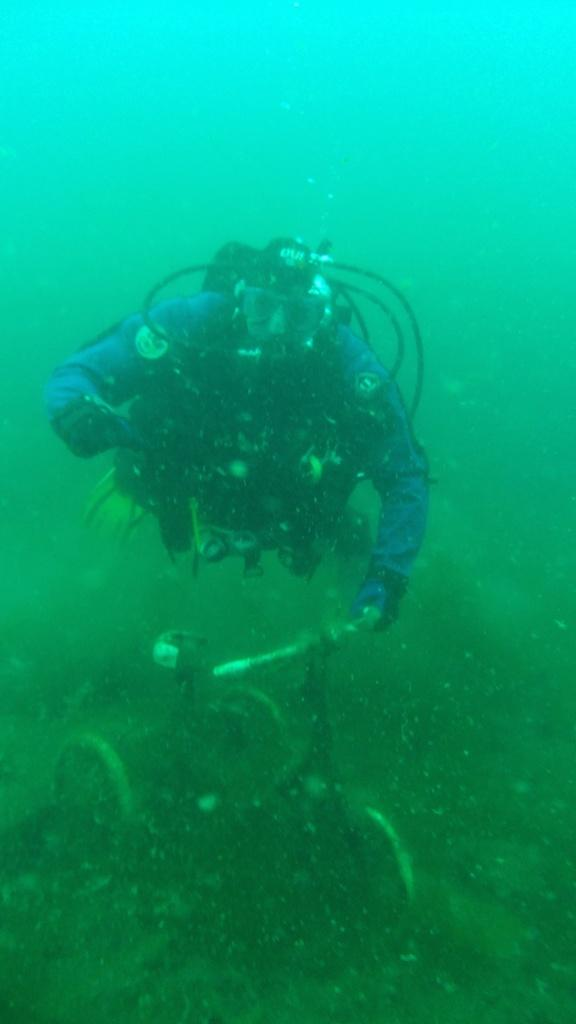Who is present in the image? There is a man in the image. What is the man wearing? The man is wearing a blue costume dress and a mask. What additional equipment does the man have? The man has an oxygen cylinder. What activity is the man engaged in? The man is swimming underwater. What is the color of the water in the image? The water in the image is blue. What type of dish is the man cooking in the image? There is no dish or cooking activity present in the image; the man is swimming underwater with an oxygen cylinder. How many waves can be seen in the image? There are no waves visible in the image, as it depicts a man swimming underwater. 